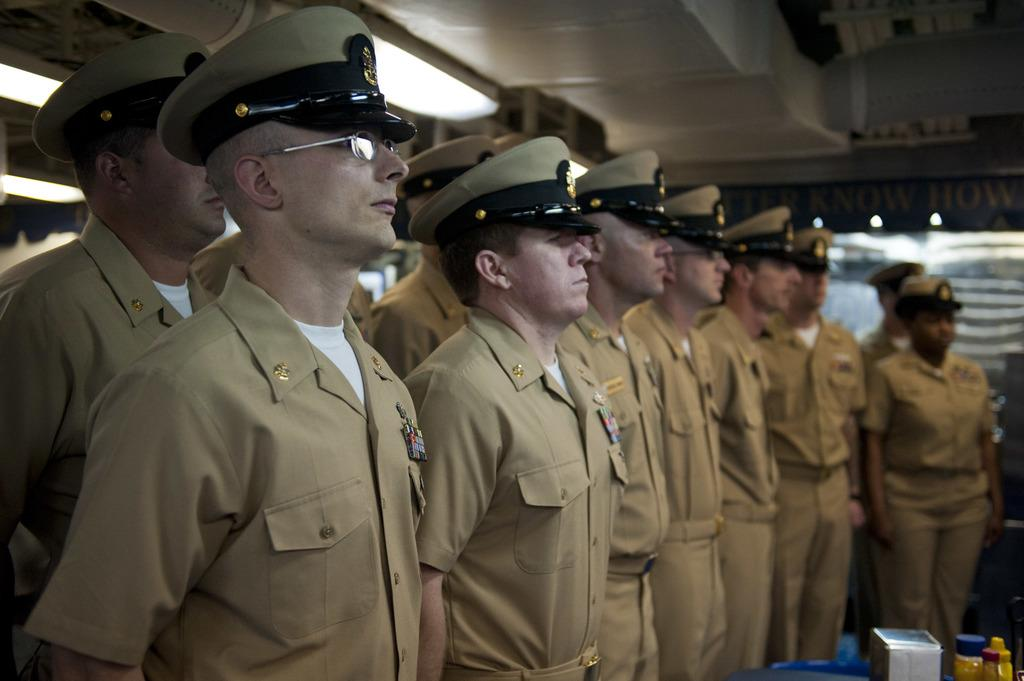How many people are in the image? There are many people in the image. What are the people wearing? The people are wearing uniforms and caps. What objects can be seen in the image besides the people? There are bottles and lights on the ceilings in the image. What type of mine is visible in the image? There is no mine present in the image. Can you describe the sink in the image? There is no sink present in the image. 